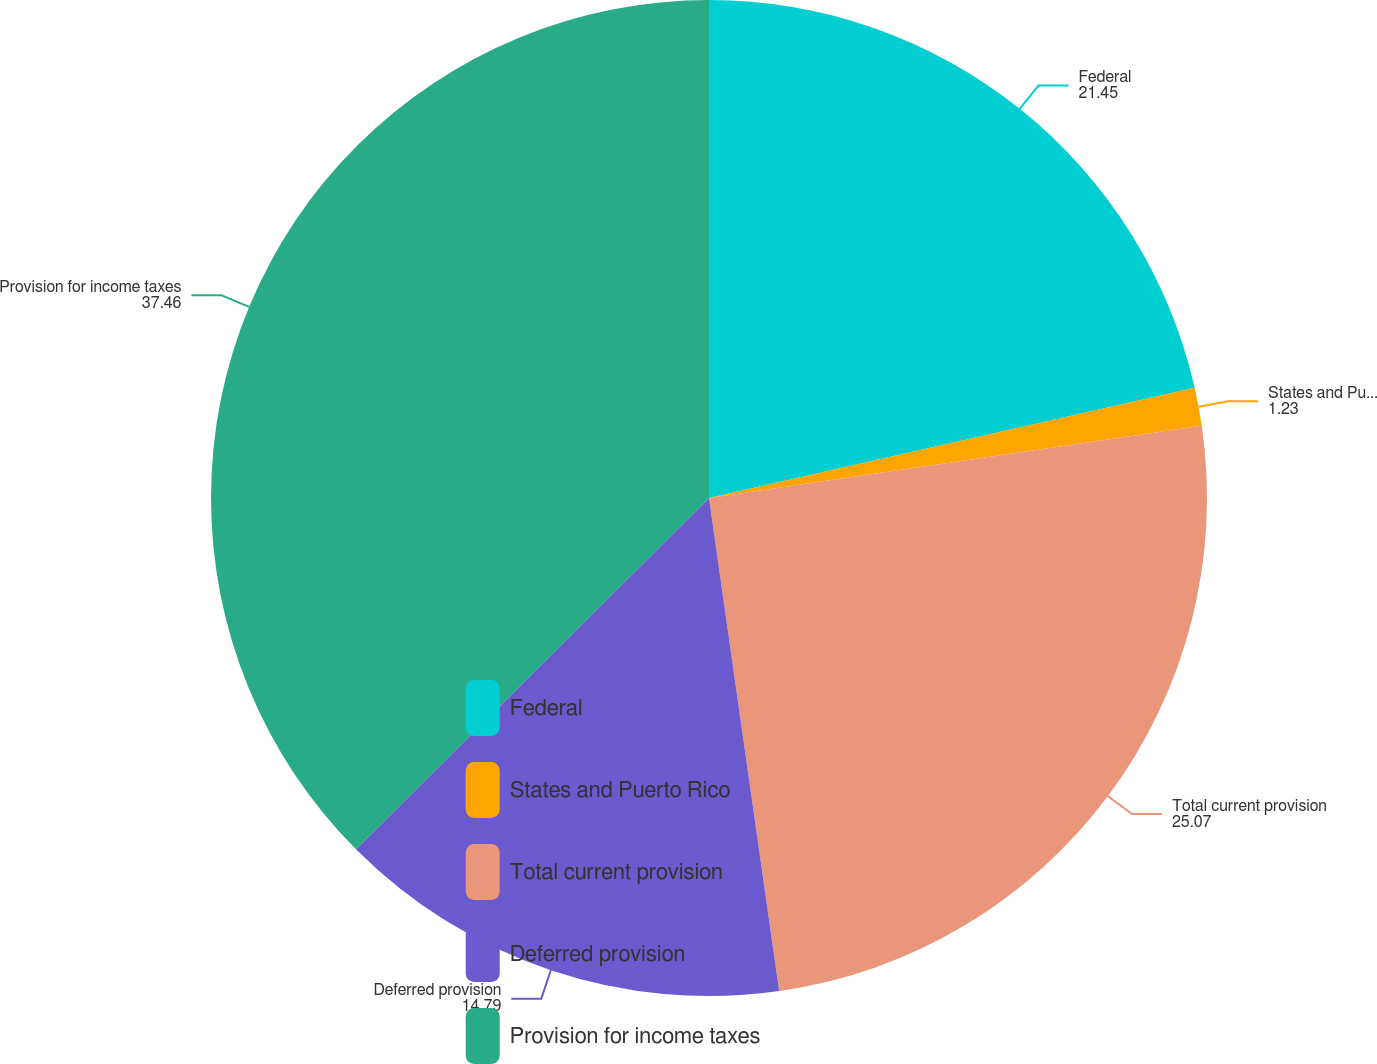<chart> <loc_0><loc_0><loc_500><loc_500><pie_chart><fcel>Federal<fcel>States and Puerto Rico<fcel>Total current provision<fcel>Deferred provision<fcel>Provision for income taxes<nl><fcel>21.45%<fcel>1.23%<fcel>25.07%<fcel>14.79%<fcel>37.46%<nl></chart> 